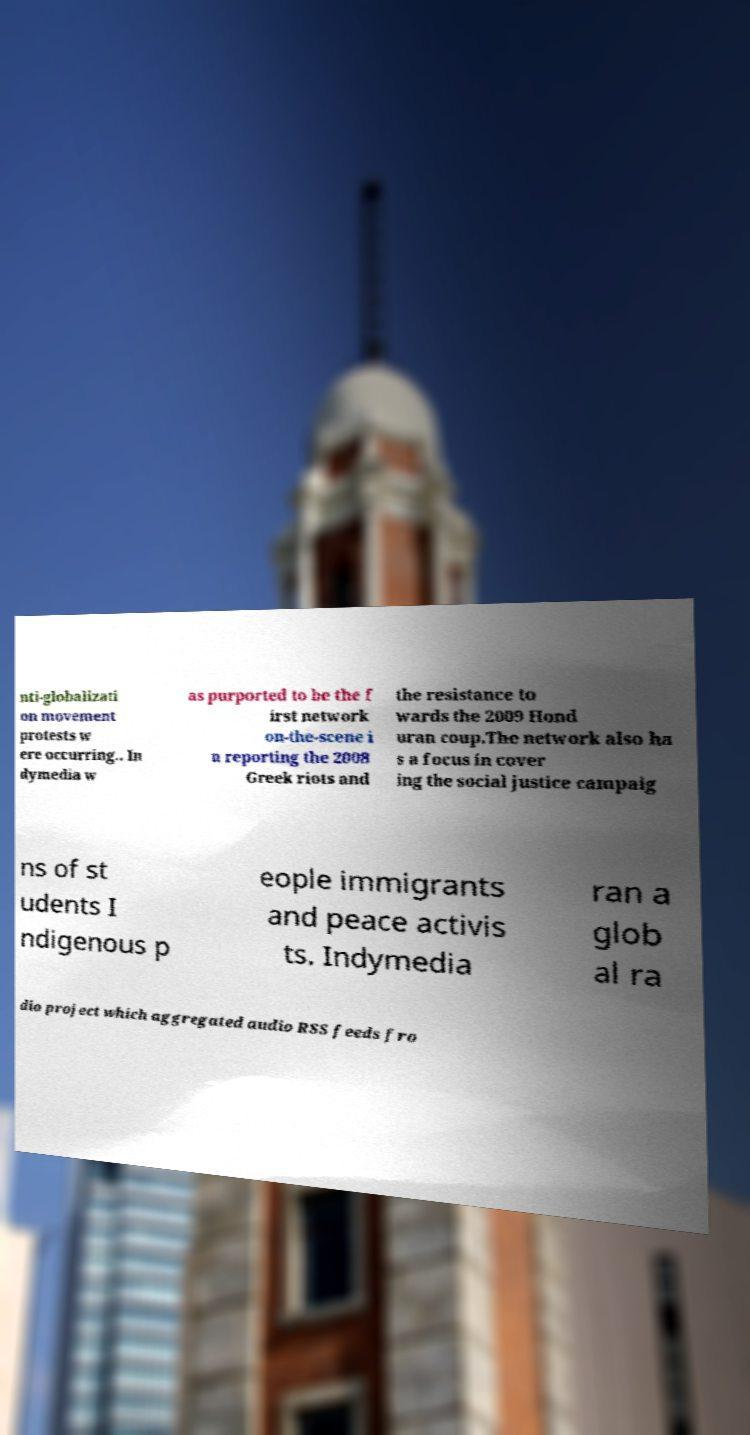What messages or text are displayed in this image? I need them in a readable, typed format. nti-globalizati on movement protests w ere occurring.. In dymedia w as purported to be the f irst network on-the-scene i n reporting the 2008 Greek riots and the resistance to wards the 2009 Hond uran coup.The network also ha s a focus in cover ing the social justice campaig ns of st udents I ndigenous p eople immigrants and peace activis ts. Indymedia ran a glob al ra dio project which aggregated audio RSS feeds fro 